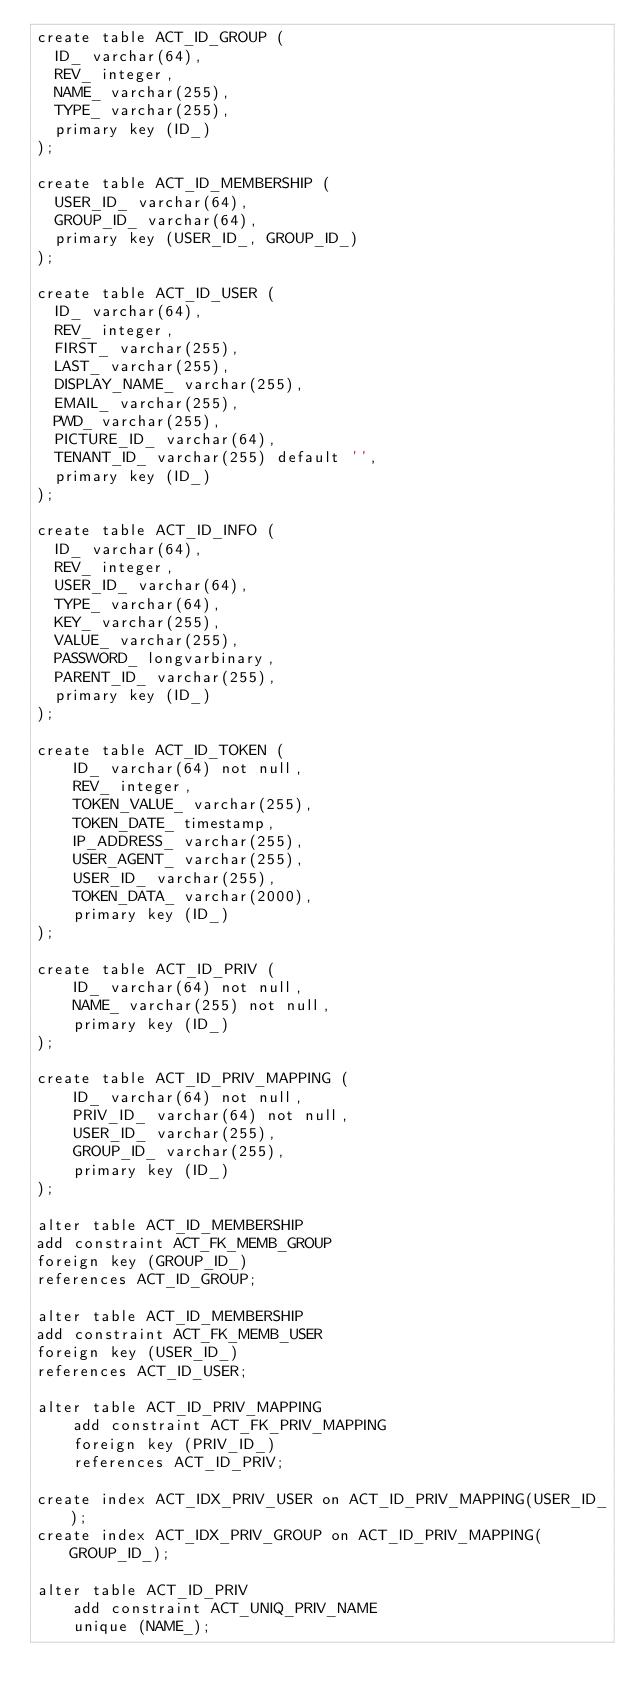<code> <loc_0><loc_0><loc_500><loc_500><_SQL_>create table ACT_ID_GROUP (
  ID_ varchar(64),
  REV_ integer,
  NAME_ varchar(255),
  TYPE_ varchar(255),
  primary key (ID_)
);

create table ACT_ID_MEMBERSHIP (
  USER_ID_ varchar(64),
  GROUP_ID_ varchar(64),
  primary key (USER_ID_, GROUP_ID_)
);

create table ACT_ID_USER (
  ID_ varchar(64),
  REV_ integer,
  FIRST_ varchar(255),
  LAST_ varchar(255),
  DISPLAY_NAME_ varchar(255),
  EMAIL_ varchar(255),
  PWD_ varchar(255),
  PICTURE_ID_ varchar(64),
  TENANT_ID_ varchar(255) default '',
  primary key (ID_)
);

create table ACT_ID_INFO (
  ID_ varchar(64),
  REV_ integer,
  USER_ID_ varchar(64),
  TYPE_ varchar(64),
  KEY_ varchar(255),
  VALUE_ varchar(255),
  PASSWORD_ longvarbinary,
  PARENT_ID_ varchar(255),
  primary key (ID_)
);

create table ACT_ID_TOKEN (
    ID_ varchar(64) not null,
    REV_ integer,
    TOKEN_VALUE_ varchar(255),
    TOKEN_DATE_ timestamp,
    IP_ADDRESS_ varchar(255),
    USER_AGENT_ varchar(255),
    USER_ID_ varchar(255),
    TOKEN_DATA_ varchar(2000),
    primary key (ID_)
);

create table ACT_ID_PRIV (
    ID_ varchar(64) not null,
    NAME_ varchar(255) not null,
    primary key (ID_)
);

create table ACT_ID_PRIV_MAPPING (
    ID_ varchar(64) not null,
    PRIV_ID_ varchar(64) not null,
    USER_ID_ varchar(255),
    GROUP_ID_ varchar(255),
    primary key (ID_)
);

alter table ACT_ID_MEMBERSHIP
add constraint ACT_FK_MEMB_GROUP
foreign key (GROUP_ID_)
references ACT_ID_GROUP;

alter table ACT_ID_MEMBERSHIP
add constraint ACT_FK_MEMB_USER
foreign key (USER_ID_)
references ACT_ID_USER;

alter table ACT_ID_PRIV_MAPPING
    add constraint ACT_FK_PRIV_MAPPING
    foreign key (PRIV_ID_)
    references ACT_ID_PRIV;

create index ACT_IDX_PRIV_USER on ACT_ID_PRIV_MAPPING(USER_ID_);
create index ACT_IDX_PRIV_GROUP on ACT_ID_PRIV_MAPPING(GROUP_ID_);

alter table ACT_ID_PRIV
    add constraint ACT_UNIQ_PRIV_NAME
    unique (NAME_);
</code> 